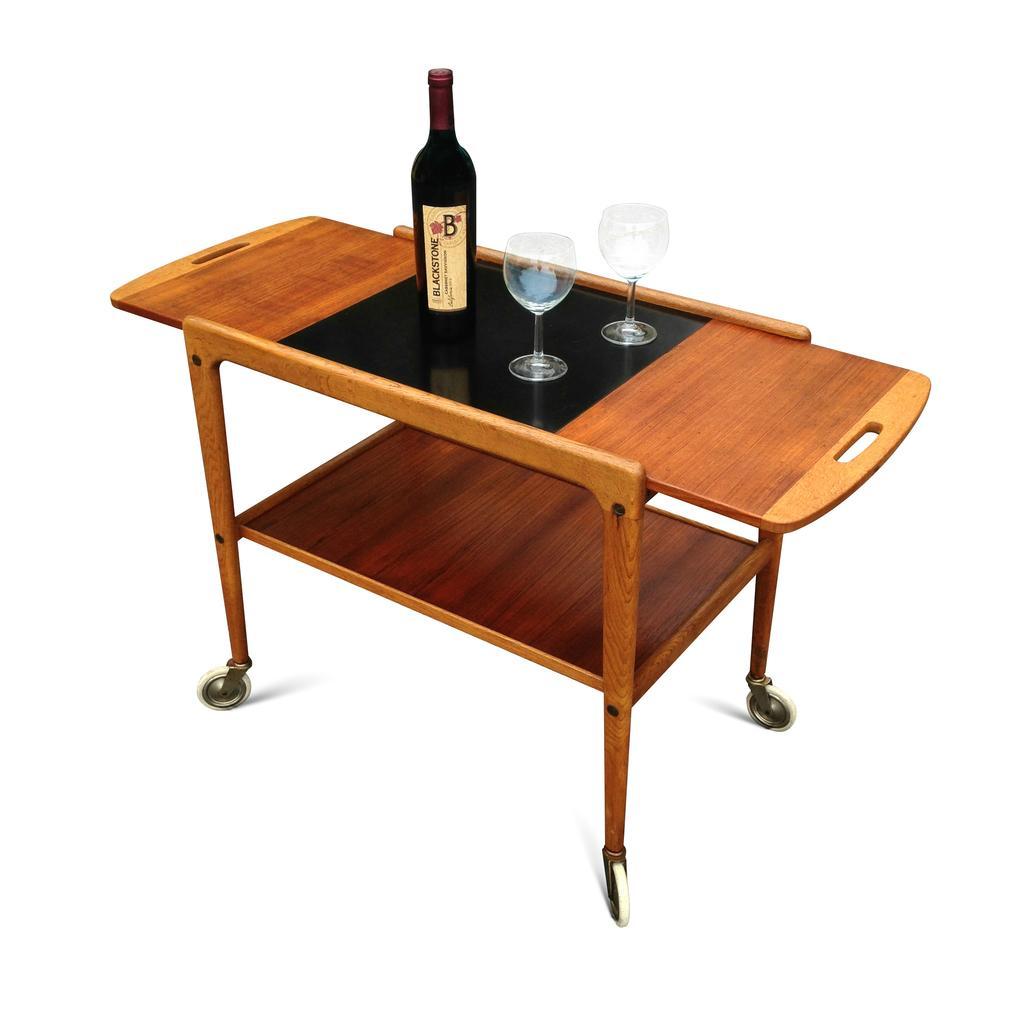Describe this image in one or two sentences. It is an animation image in which there is a table. On the table there is a glass bottle and two glasses beside it. 